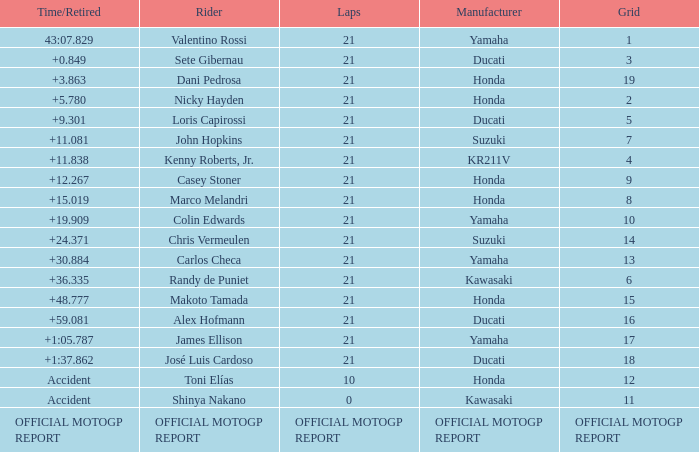How many laps did Valentino rossi have when riding a vehicle manufactured by yamaha? 21.0. 